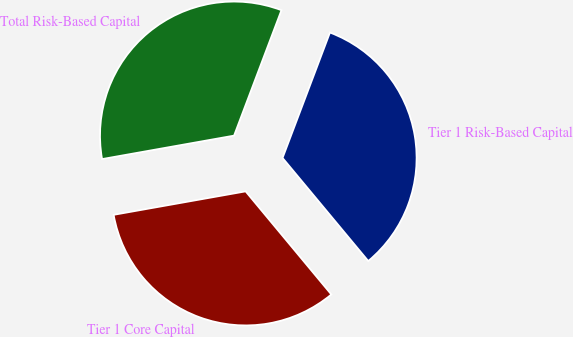Convert chart to OTSL. <chart><loc_0><loc_0><loc_500><loc_500><pie_chart><fcel>Tier 1 Risk-Based Capital<fcel>Total Risk-Based Capital<fcel>Tier 1 Core Capital<nl><fcel>33.21%<fcel>33.55%<fcel>33.24%<nl></chart> 